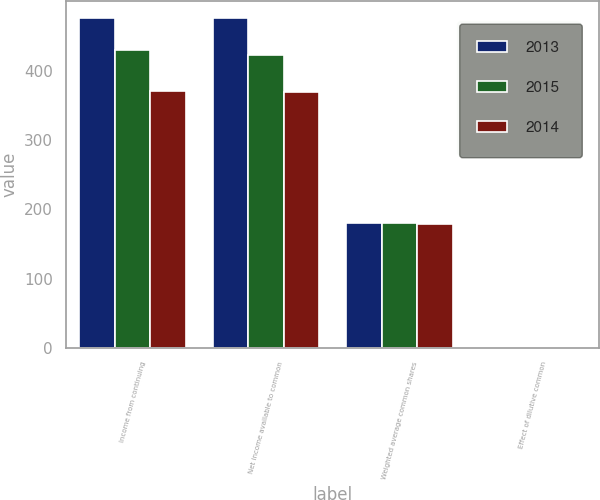<chart> <loc_0><loc_0><loc_500><loc_500><stacked_bar_chart><ecel><fcel>Income from continuing<fcel>Net income available to common<fcel>Weighted average common shares<fcel>Effect of dilutive common<nl><fcel>2013<fcel>476<fcel>476<fcel>180<fcel>1<nl><fcel>2015<fcel>430<fcel>423<fcel>180<fcel>1<nl><fcel>2014<fcel>371<fcel>369<fcel>179<fcel>1<nl></chart> 